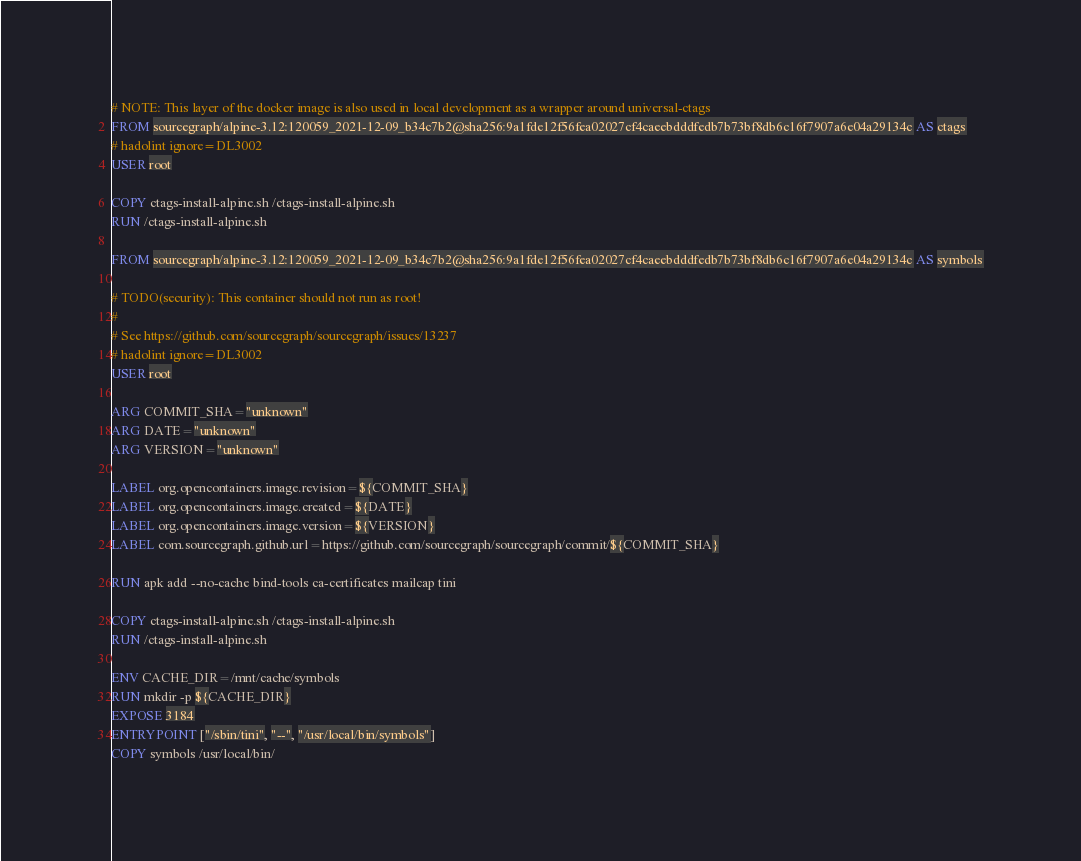<code> <loc_0><loc_0><loc_500><loc_500><_Dockerfile_># NOTE: This layer of the docker image is also used in local development as a wrapper around universal-ctags
FROM sourcegraph/alpine-3.12:120059_2021-12-09_b34c7b2@sha256:9a1fde12f56fea02027cf4caeebdddfedb7b73bf8db6c16f7907a6e04a29134c AS ctags
# hadolint ignore=DL3002
USER root

COPY ctags-install-alpine.sh /ctags-install-alpine.sh
RUN /ctags-install-alpine.sh

FROM sourcegraph/alpine-3.12:120059_2021-12-09_b34c7b2@sha256:9a1fde12f56fea02027cf4caeebdddfedb7b73bf8db6c16f7907a6e04a29134c AS symbols

# TODO(security): This container should not run as root!
#
# See https://github.com/sourcegraph/sourcegraph/issues/13237
# hadolint ignore=DL3002
USER root

ARG COMMIT_SHA="unknown"
ARG DATE="unknown"
ARG VERSION="unknown"

LABEL org.opencontainers.image.revision=${COMMIT_SHA}
LABEL org.opencontainers.image.created=${DATE}
LABEL org.opencontainers.image.version=${VERSION}
LABEL com.sourcegraph.github.url=https://github.com/sourcegraph/sourcegraph/commit/${COMMIT_SHA}

RUN apk add --no-cache bind-tools ca-certificates mailcap tini

COPY ctags-install-alpine.sh /ctags-install-alpine.sh
RUN /ctags-install-alpine.sh

ENV CACHE_DIR=/mnt/cache/symbols
RUN mkdir -p ${CACHE_DIR}
EXPOSE 3184
ENTRYPOINT ["/sbin/tini", "--", "/usr/local/bin/symbols"]
COPY symbols /usr/local/bin/
</code> 